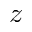<formula> <loc_0><loc_0><loc_500><loc_500>z</formula> 